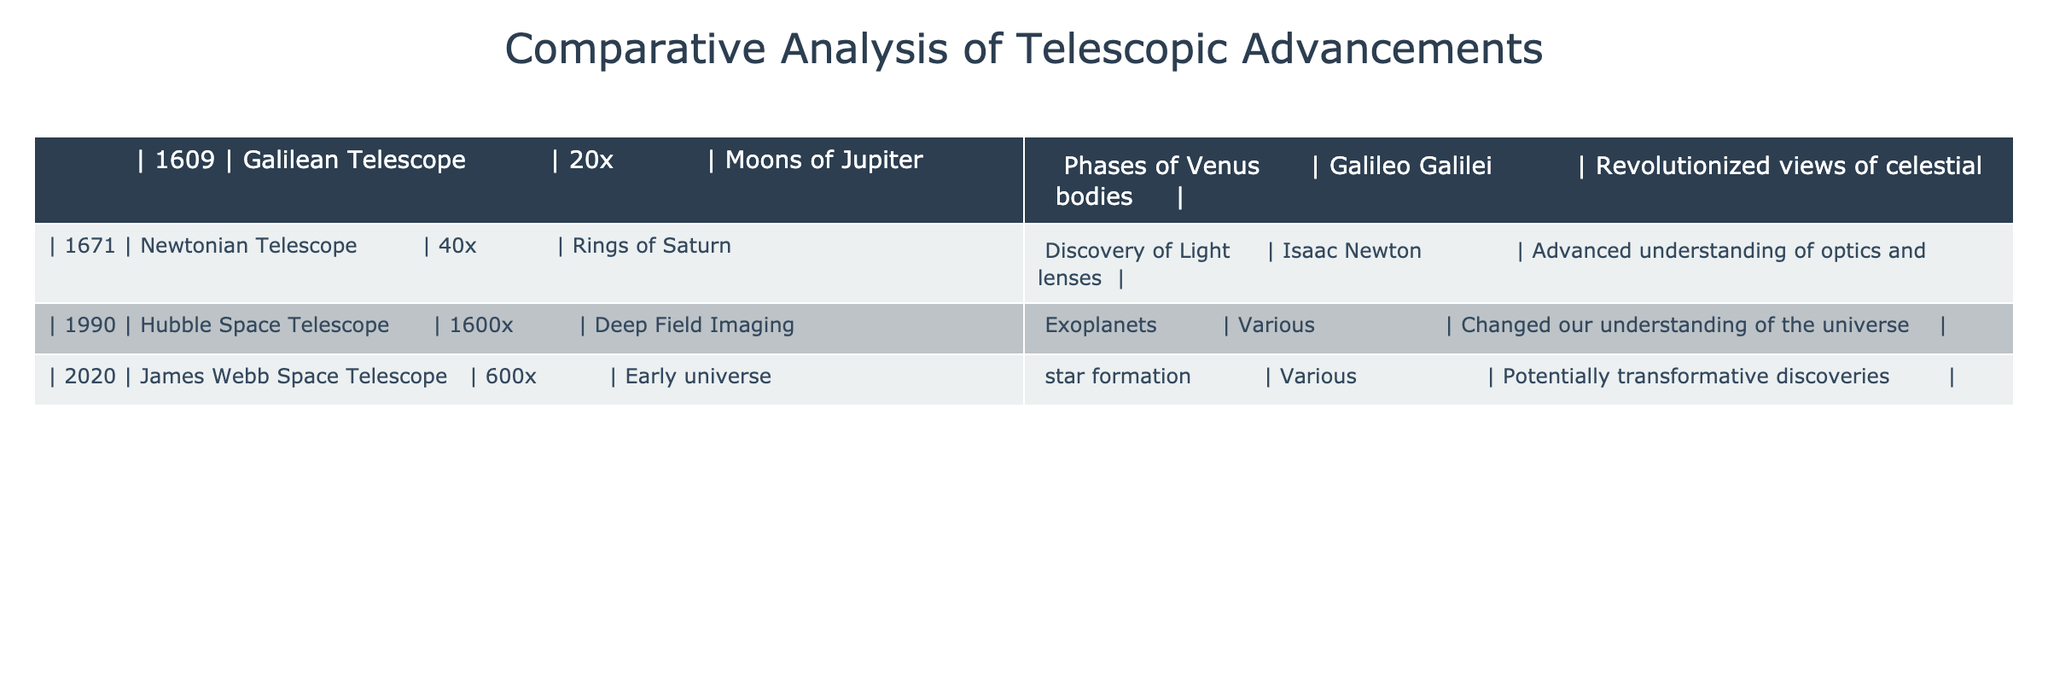What is the magnification of the Hubble Space Telescope? The table lists the specifications of various telescopes, including their magnification. The Hubble Space Telescope's magnification is stated as 1600x.
Answer: 1600x Who invented the Newtonian Telescope? According to the table, the Newtonian Telescope was invented by Isaac Newton, as listed in the relevant column.
Answer: Isaac Newton What major discovery was made using the Galilean Telescope? The table specifies that the Galilean Telescope was used to discover the Moons of Jupiter and the Phases of Venus, which are major discoveries.
Answer: Moons of Jupiter, Phases of Venus Does the James Webb Space Telescope have a higher magnification than the Hubble Space Telescope? Comparing the magnifications, the James Webb Space Telescope has a magnification of 600x, which is lower than the Hubble Space Telescope’s 1600x. Thus, the statement is false.
Answer: No Which telescope had the highest magnification and what were its impacts? The table shows that the Hubble Space Telescope had the highest magnification at 1600x. Its impact included changing our understanding of the universe through deep field imaging and the discovery of exoplanets.
Answer: Hubble Space Telescope; changed our understanding of the universe What year saw the introduction of the first telescope listed in the table? The first telescope in the table is the Galilean Telescope, introduced in 1609.
Answer: 1609 What temporal gap exists between the invention of the Newtonian Telescope and the Hubble Space Telescope? The Newtonian Telescope was invented in 1671, and the Hubble Space Telescope was introduced in 1990. Therefore, the gap is 1990 - 1671 = 319 years.
Answer: 319 years How many telescopes are listed in the table, and what trend can be seen over the years? There are four telescopes listed. The trend shows that telescopes have increased magnification capability significantly over the years, from 20x to 600x.
Answer: Four; increasing magnification trend Is the James Webb Space Telescope's purpose similar to that of the Hubble Space Telescope? Both telescopes focus on astronomical discoveries, but the James Webb Space Telescope specifically targets early universe observations and star formation, while Hubble had a broader role. This makes the purpose somewhat similar but not identical.
Answer: Yes, somewhat similar What was the significance of the discovery made with the Newtonian Telescope? The Newtonian Telescope advanced our understanding of optics and lenses, particularly through the discovery of light and the rings of Saturn, as noted in the table.
Answer: Advanced understanding of optics and lenses 